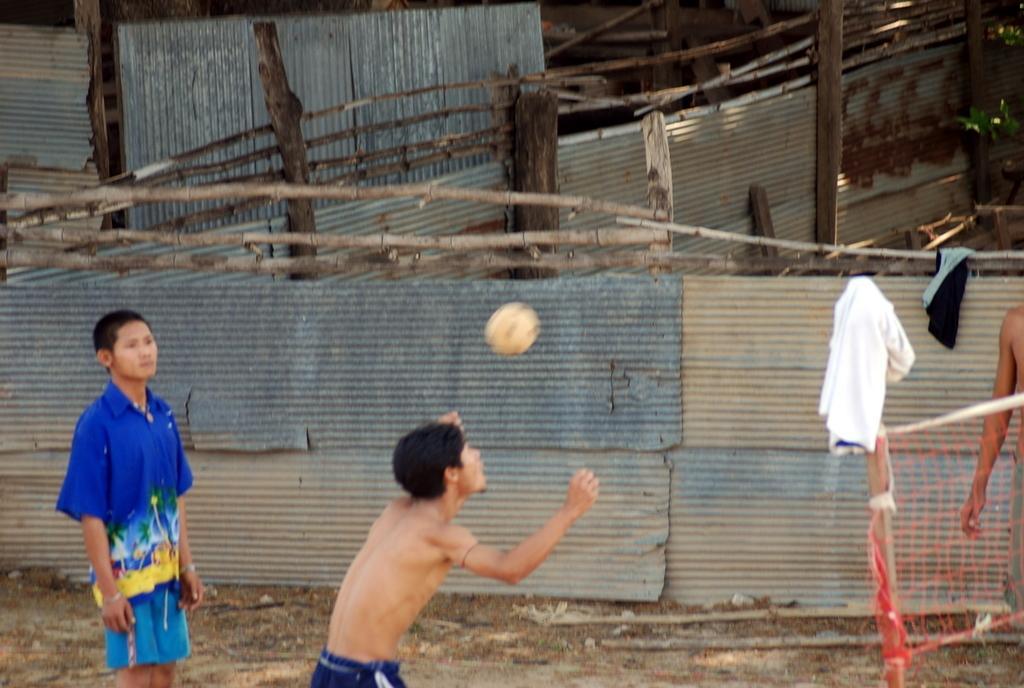In one or two sentences, can you explain what this image depicts? In this picture there are people and we can see ball in the air, cloth on pole and net. In the background of the image we can see metal sheets, cloth, wooden fence and wooden poles. 